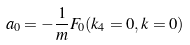<formula> <loc_0><loc_0><loc_500><loc_500>a _ { 0 } = - \frac { 1 } { m } F _ { 0 } ( k _ { 4 } = 0 , k = 0 )</formula> 